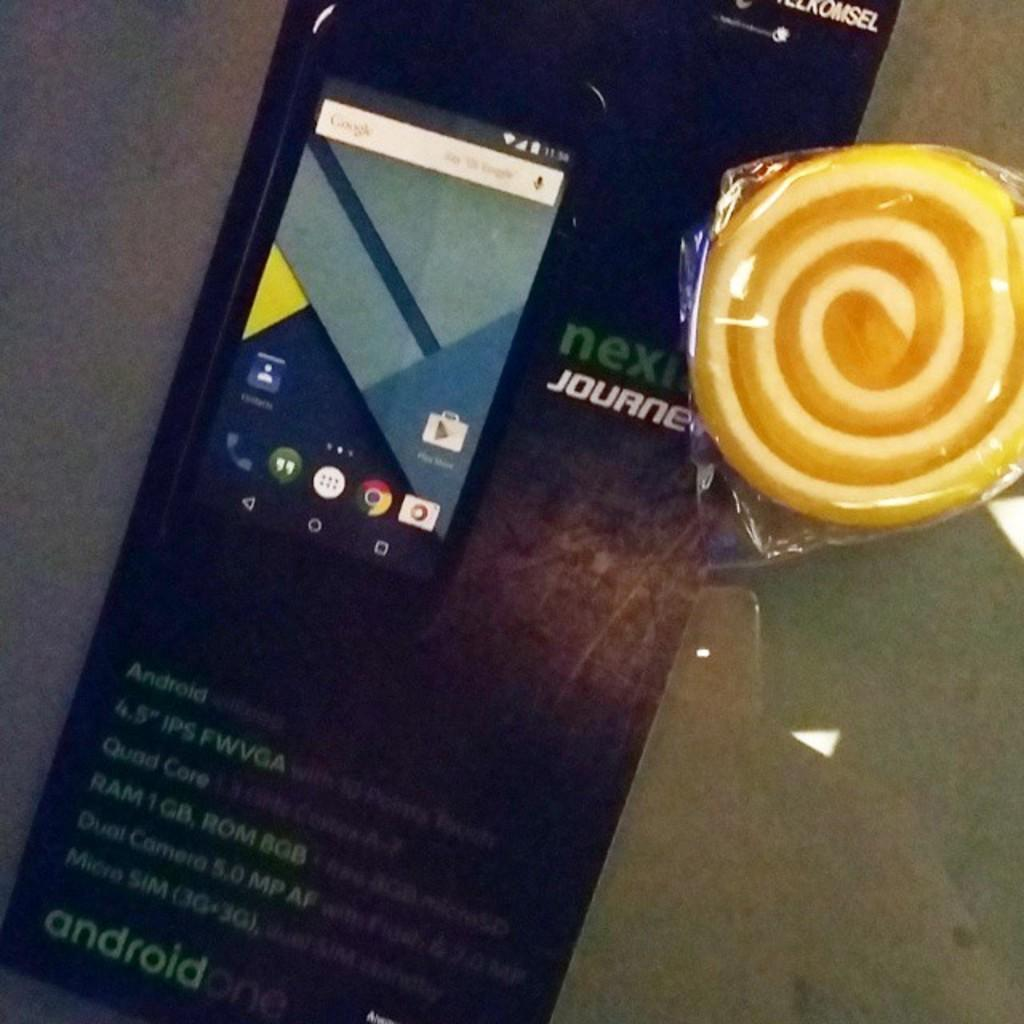<image>
Give a short and clear explanation of the subsequent image. a cellphone on a piece of paper saying 'next journey' 